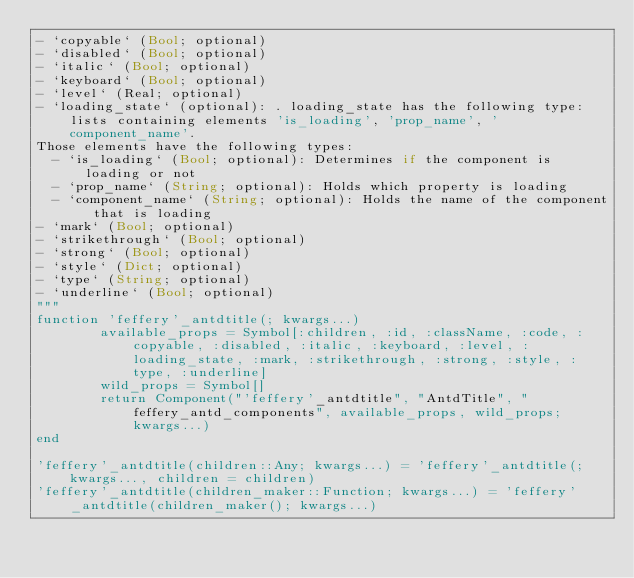<code> <loc_0><loc_0><loc_500><loc_500><_Julia_>- `copyable` (Bool; optional)
- `disabled` (Bool; optional)
- `italic` (Bool; optional)
- `keyboard` (Bool; optional)
- `level` (Real; optional)
- `loading_state` (optional): . loading_state has the following type: lists containing elements 'is_loading', 'prop_name', 'component_name'.
Those elements have the following types:
  - `is_loading` (Bool; optional): Determines if the component is loading or not
  - `prop_name` (String; optional): Holds which property is loading
  - `component_name` (String; optional): Holds the name of the component that is loading
- `mark` (Bool; optional)
- `strikethrough` (Bool; optional)
- `strong` (Bool; optional)
- `style` (Dict; optional)
- `type` (String; optional)
- `underline` (Bool; optional)
"""
function 'feffery'_antdtitle(; kwargs...)
        available_props = Symbol[:children, :id, :className, :code, :copyable, :disabled, :italic, :keyboard, :level, :loading_state, :mark, :strikethrough, :strong, :style, :type, :underline]
        wild_props = Symbol[]
        return Component("'feffery'_antdtitle", "AntdTitle", "feffery_antd_components", available_props, wild_props; kwargs...)
end

'feffery'_antdtitle(children::Any; kwargs...) = 'feffery'_antdtitle(;kwargs..., children = children)
'feffery'_antdtitle(children_maker::Function; kwargs...) = 'feffery'_antdtitle(children_maker(); kwargs...)

</code> 